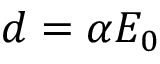<formula> <loc_0><loc_0><loc_500><loc_500>d = \alpha E _ { 0 }</formula> 